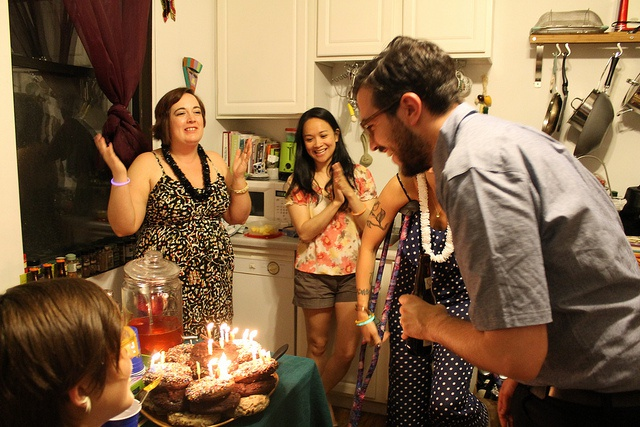Describe the objects in this image and their specific colors. I can see people in khaki, black, maroon, lightgray, and brown tones, people in khaki, black, orange, brown, and maroon tones, dining table in khaki, black, tan, maroon, and brown tones, people in khaki, black, maroon, and brown tones, and people in khaki, black, orange, maroon, and brown tones in this image. 